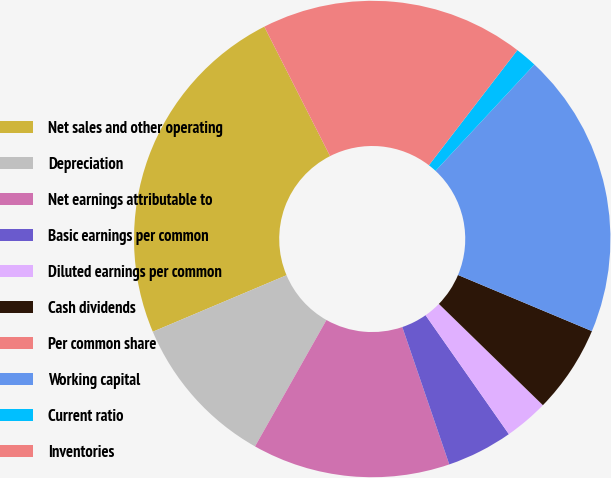<chart> <loc_0><loc_0><loc_500><loc_500><pie_chart><fcel>Net sales and other operating<fcel>Depreciation<fcel>Net earnings attributable to<fcel>Basic earnings per common<fcel>Diluted earnings per common<fcel>Cash dividends<fcel>Per common share<fcel>Working capital<fcel>Current ratio<fcel>Inventories<nl><fcel>23.88%<fcel>10.45%<fcel>13.43%<fcel>4.48%<fcel>2.99%<fcel>5.97%<fcel>0.0%<fcel>19.4%<fcel>1.49%<fcel>17.91%<nl></chart> 